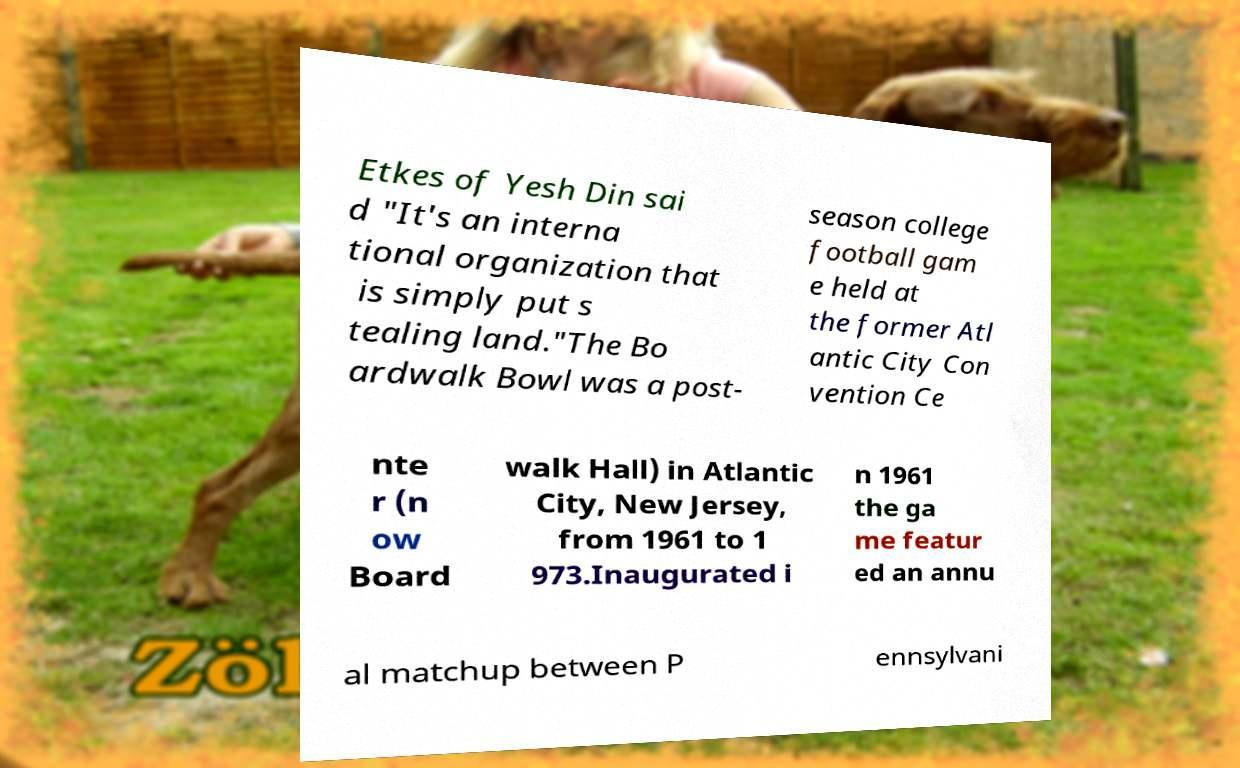Please read and relay the text visible in this image. What does it say? Etkes of Yesh Din sai d "It's an interna tional organization that is simply put s tealing land."The Bo ardwalk Bowl was a post- season college football gam e held at the former Atl antic City Con vention Ce nte r (n ow Board walk Hall) in Atlantic City, New Jersey, from 1961 to 1 973.Inaugurated i n 1961 the ga me featur ed an annu al matchup between P ennsylvani 